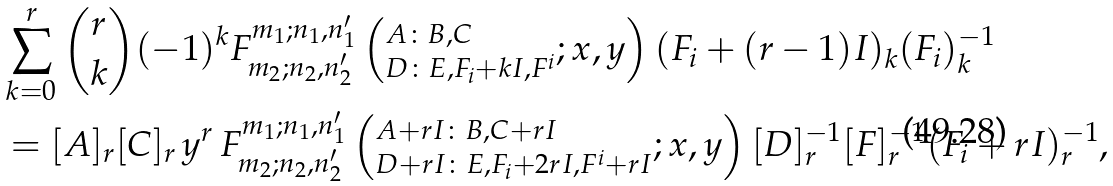<formula> <loc_0><loc_0><loc_500><loc_500>& \sum _ { k = 0 } ^ { r } { r \choose k } { ( - 1 ) ^ { k } F ^ { m _ { 1 } ; n _ { 1 } , n ^ { \prime } _ { 1 } } _ { m _ { 2 } ; n _ { 2 } , n ^ { \prime } _ { 2 } } \left ( ^ { A \colon B , C } _ { D \colon E , F _ { i } + k I , F ^ { i } } ; x , y \right ) ( F _ { i } + ( r - 1 ) I ) _ { k } } { ( F _ { i } ) ^ { - 1 } _ { k } } \\ & = { [ A ] _ { r } [ C ] _ { r } } \, y ^ { r } \, F ^ { m _ { 1 } ; n _ { 1 } , n ^ { \prime } _ { 1 } } _ { m _ { 2 } ; n _ { 2 } , n ^ { \prime } _ { 2 } } \left ( ^ { A + r I \colon B , C + r I } _ { D + r I \colon E , F _ { i } + 2 r I , F ^ { i } + r I } ; x , y \right ) { [ D ] ^ { - 1 } _ { r } [ F ] ^ { - 1 } _ { r } ( F _ { i } + r I ) ^ { - 1 } _ { r } } ,</formula> 